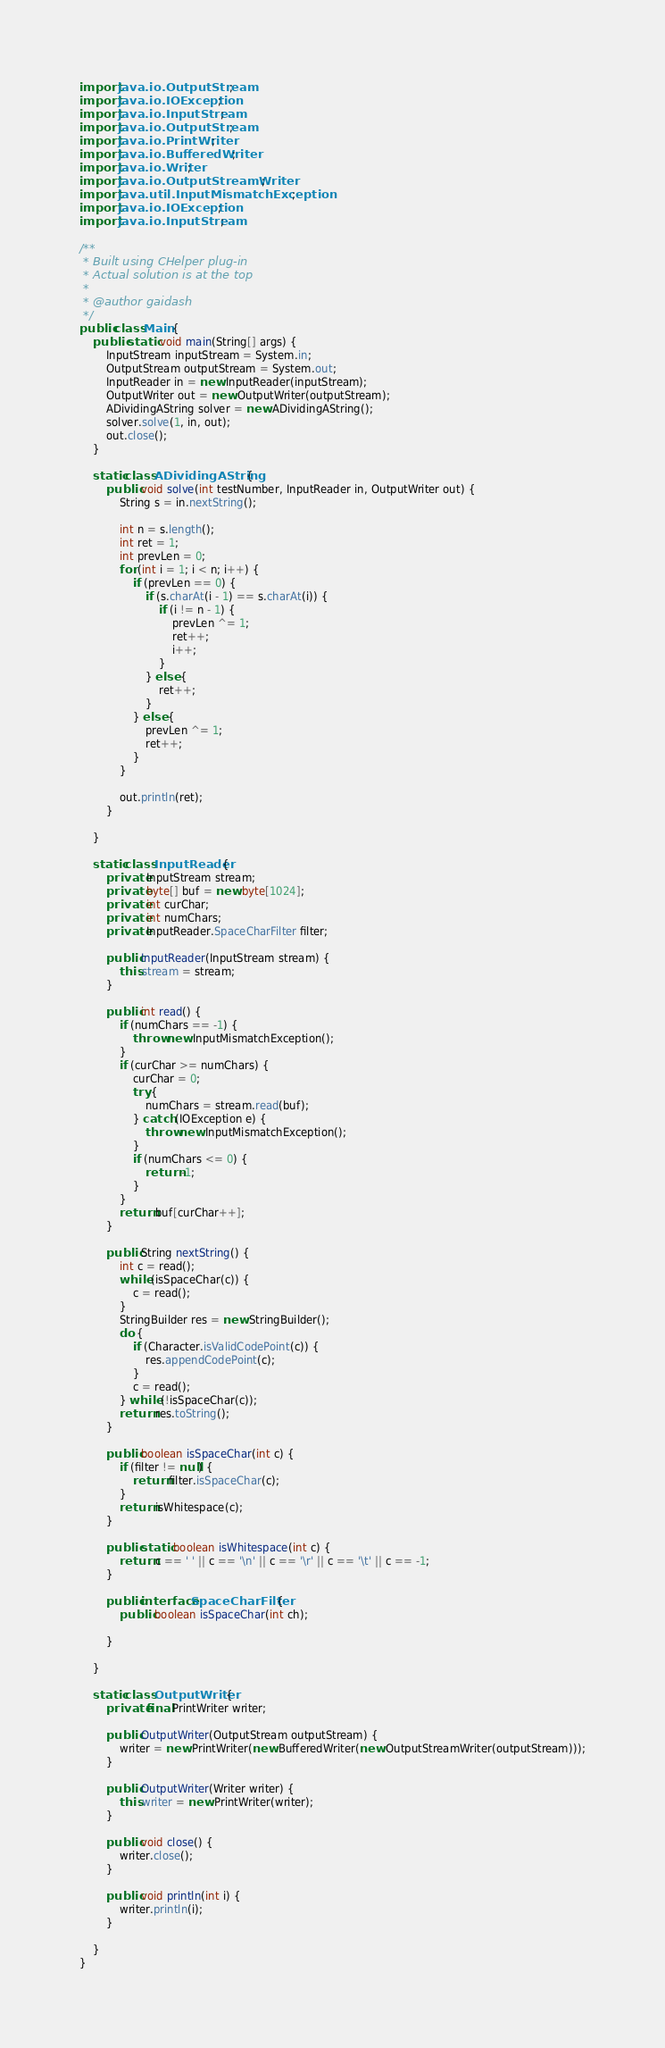Convert code to text. <code><loc_0><loc_0><loc_500><loc_500><_Java_>import java.io.OutputStream;
import java.io.IOException;
import java.io.InputStream;
import java.io.OutputStream;
import java.io.PrintWriter;
import java.io.BufferedWriter;
import java.io.Writer;
import java.io.OutputStreamWriter;
import java.util.InputMismatchException;
import java.io.IOException;
import java.io.InputStream;

/**
 * Built using CHelper plug-in
 * Actual solution is at the top
 *
 * @author gaidash
 */
public class Main {
    public static void main(String[] args) {
        InputStream inputStream = System.in;
        OutputStream outputStream = System.out;
        InputReader in = new InputReader(inputStream);
        OutputWriter out = new OutputWriter(outputStream);
        ADividingAString solver = new ADividingAString();
        solver.solve(1, in, out);
        out.close();
    }

    static class ADividingAString {
        public void solve(int testNumber, InputReader in, OutputWriter out) {
            String s = in.nextString();

            int n = s.length();
            int ret = 1;
            int prevLen = 0;
            for (int i = 1; i < n; i++) {
                if (prevLen == 0) {
                    if (s.charAt(i - 1) == s.charAt(i)) {
                        if (i != n - 1) {
                            prevLen ^= 1;
                            ret++;
                            i++;
                        }
                    } else {
                        ret++;
                    }
                } else {
                    prevLen ^= 1;
                    ret++;
                }
            }

            out.println(ret);
        }

    }

    static class InputReader {
        private InputStream stream;
        private byte[] buf = new byte[1024];
        private int curChar;
        private int numChars;
        private InputReader.SpaceCharFilter filter;

        public InputReader(InputStream stream) {
            this.stream = stream;
        }

        public int read() {
            if (numChars == -1) {
                throw new InputMismatchException();
            }
            if (curChar >= numChars) {
                curChar = 0;
                try {
                    numChars = stream.read(buf);
                } catch (IOException e) {
                    throw new InputMismatchException();
                }
                if (numChars <= 0) {
                    return -1;
                }
            }
            return buf[curChar++];
        }

        public String nextString() {
            int c = read();
            while (isSpaceChar(c)) {
                c = read();
            }
            StringBuilder res = new StringBuilder();
            do {
                if (Character.isValidCodePoint(c)) {
                    res.appendCodePoint(c);
                }
                c = read();
            } while (!isSpaceChar(c));
            return res.toString();
        }

        public boolean isSpaceChar(int c) {
            if (filter != null) {
                return filter.isSpaceChar(c);
            }
            return isWhitespace(c);
        }

        public static boolean isWhitespace(int c) {
            return c == ' ' || c == '\n' || c == '\r' || c == '\t' || c == -1;
        }

        public interface SpaceCharFilter {
            public boolean isSpaceChar(int ch);

        }

    }

    static class OutputWriter {
        private final PrintWriter writer;

        public OutputWriter(OutputStream outputStream) {
            writer = new PrintWriter(new BufferedWriter(new OutputStreamWriter(outputStream)));
        }

        public OutputWriter(Writer writer) {
            this.writer = new PrintWriter(writer);
        }

        public void close() {
            writer.close();
        }

        public void println(int i) {
            writer.println(i);
        }

    }
}

</code> 